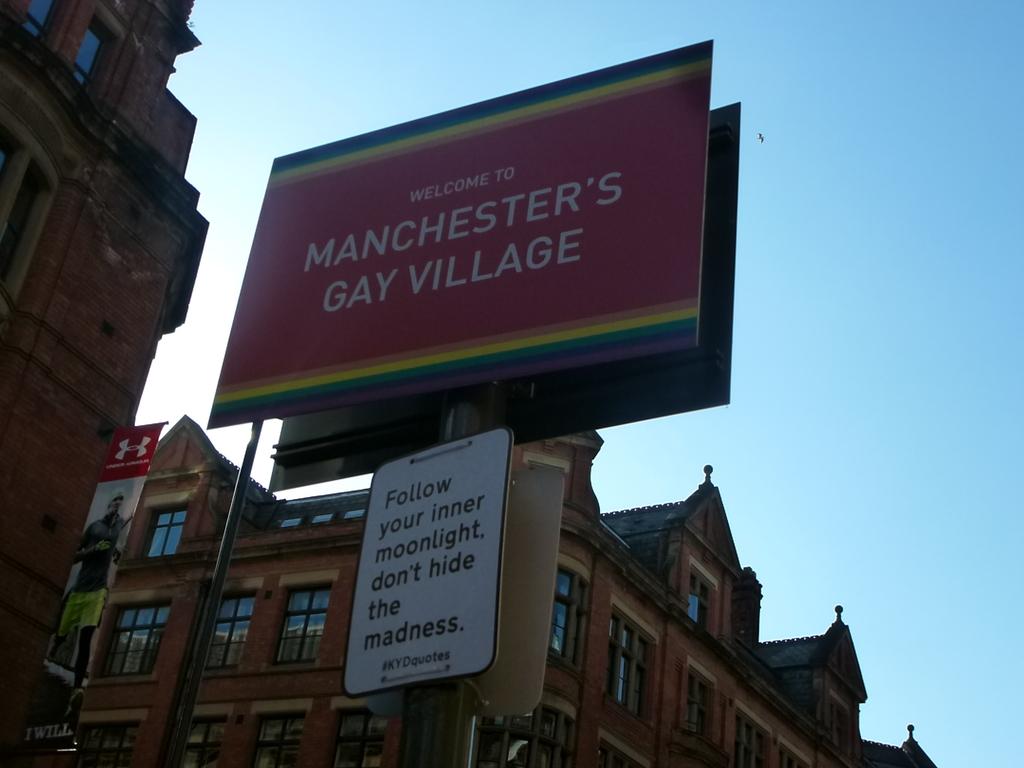What kind of village is this?
Keep it short and to the point. Gay. Where is the village?
Make the answer very short. Manchester. 